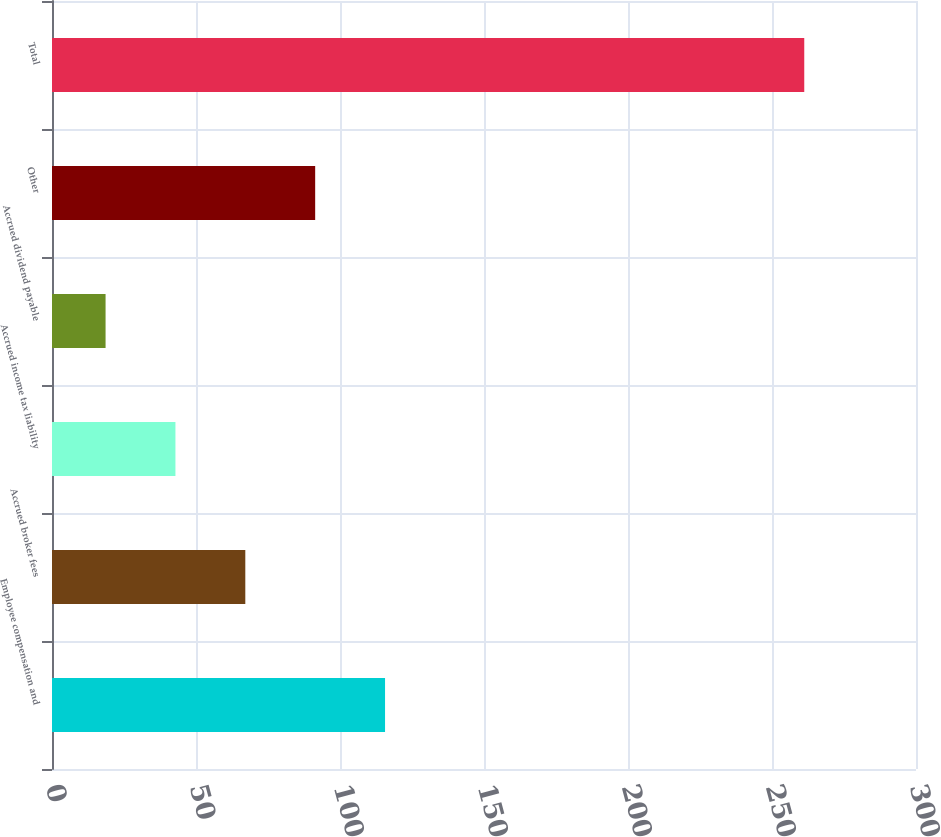<chart> <loc_0><loc_0><loc_500><loc_500><bar_chart><fcel>Employee compensation and<fcel>Accrued broker fees<fcel>Accrued income tax liability<fcel>Accrued dividend payable<fcel>Other<fcel>Total<nl><fcel>115.64<fcel>67.12<fcel>42.86<fcel>18.6<fcel>91.38<fcel>261.2<nl></chart> 